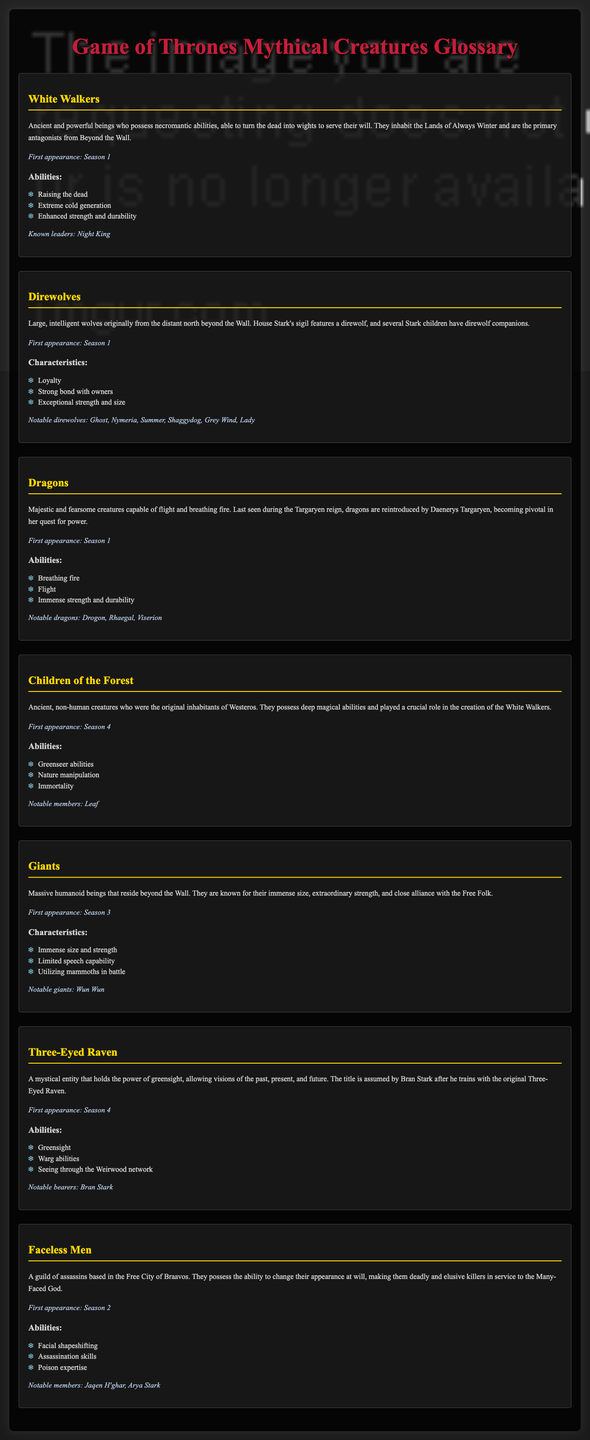What are White Walkers? White Walkers are ancient and powerful beings who possess necromantic abilities and inhabit the Lands of Always Winter.
Answer: Ancient and powerful beings What is the first appearance of Dragons? The first appearance date of Dragons is mentioned in the document.
Answer: Season 1 Who is a notable member of the Faceless Men? The document lists notable members of the Faceless Men.
Answer: Jaqen H'ghar What abilities do Children of the Forest possess? The document describes the abilities of the Children of the Forest, which include greenseer abilities.
Answer: Greenseer abilities What is the notable giant mentioned in the document? The document specifies notable giants and their names.
Answer: Wun Wun How many notable direwolves are mentioned? The document lists notable direwolves under their respective section, and the count of notable direwolves can be derived.
Answer: Six What is the main role of the Three-Eyed Raven? The document outlines the role of the Three-Eyed Raven in holding the power of greensight.
Answer: Holds the power of greensight What is the purpose of the Faceless Men? The document summarizes the role of the Faceless Men and their affiliation.
Answer: Assassins serving the Many-Faced God What is the first appearance of Giants? The document states when Giants first appear in the series.
Answer: Season 3 